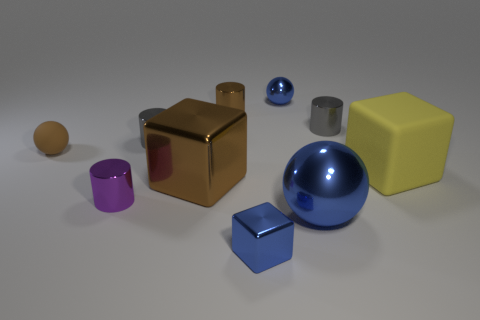Is the small shiny block the same color as the big sphere?
Your answer should be compact. Yes. Does the small rubber ball have the same color as the large cube left of the yellow rubber object?
Provide a short and direct response. Yes. Are there fewer yellow blocks on the left side of the big rubber cube than blue shiny blocks?
Your answer should be very brief. Yes. How many other objects are the same size as the purple metal cylinder?
Give a very brief answer. 6. There is a small blue metal object that is in front of the brown block; does it have the same shape as the large yellow thing?
Offer a very short reply. Yes. Is the number of small blue cubes that are right of the tiny metallic block greater than the number of objects?
Provide a short and direct response. No. There is a ball that is to the right of the big brown metallic thing and behind the large yellow object; what is its material?
Make the answer very short. Metal. Is there any other thing that is the same shape as the yellow matte object?
Your answer should be very brief. Yes. What number of metallic things are both left of the tiny shiny ball and behind the tiny cube?
Your response must be concise. 4. What is the small blue block made of?
Provide a succinct answer. Metal. 